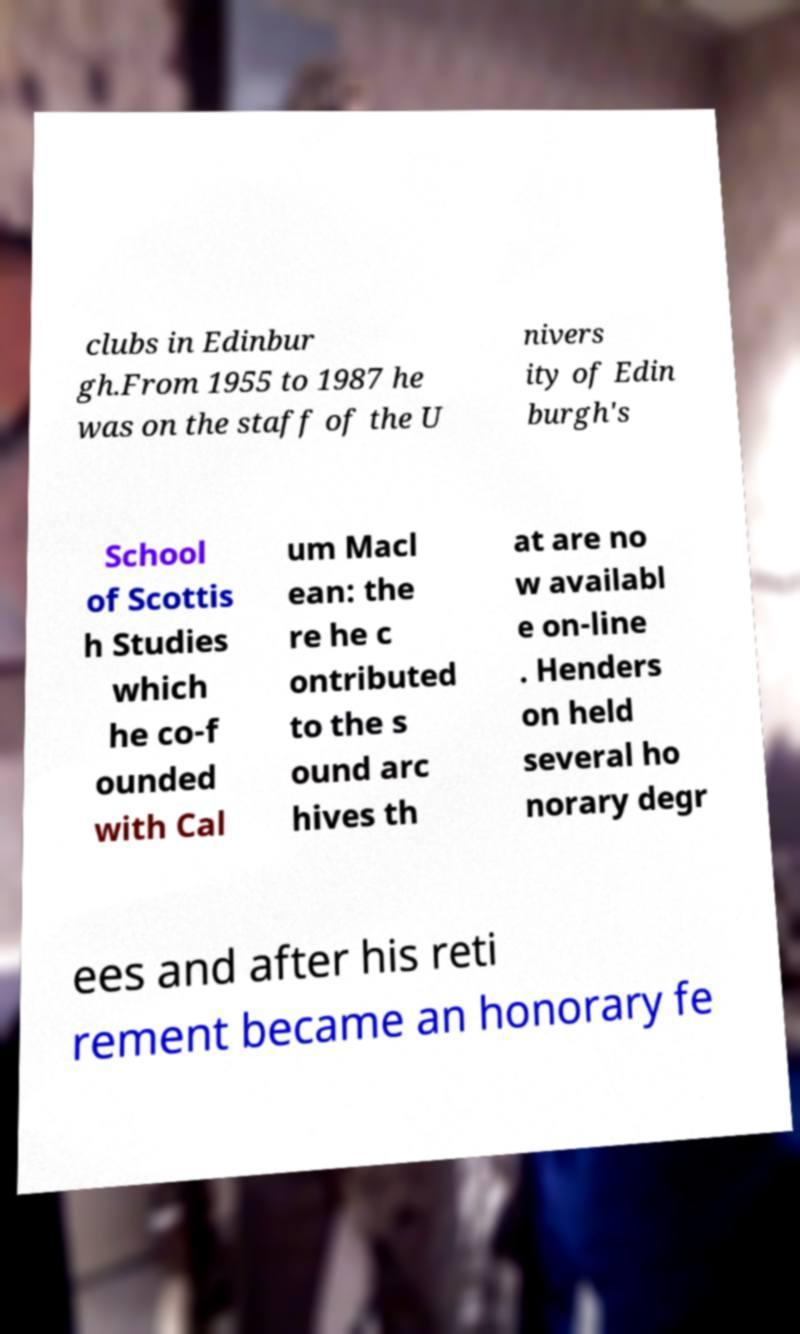Please identify and transcribe the text found in this image. clubs in Edinbur gh.From 1955 to 1987 he was on the staff of the U nivers ity of Edin burgh's School of Scottis h Studies which he co-f ounded with Cal um Macl ean: the re he c ontributed to the s ound arc hives th at are no w availabl e on-line . Henders on held several ho norary degr ees and after his reti rement became an honorary fe 